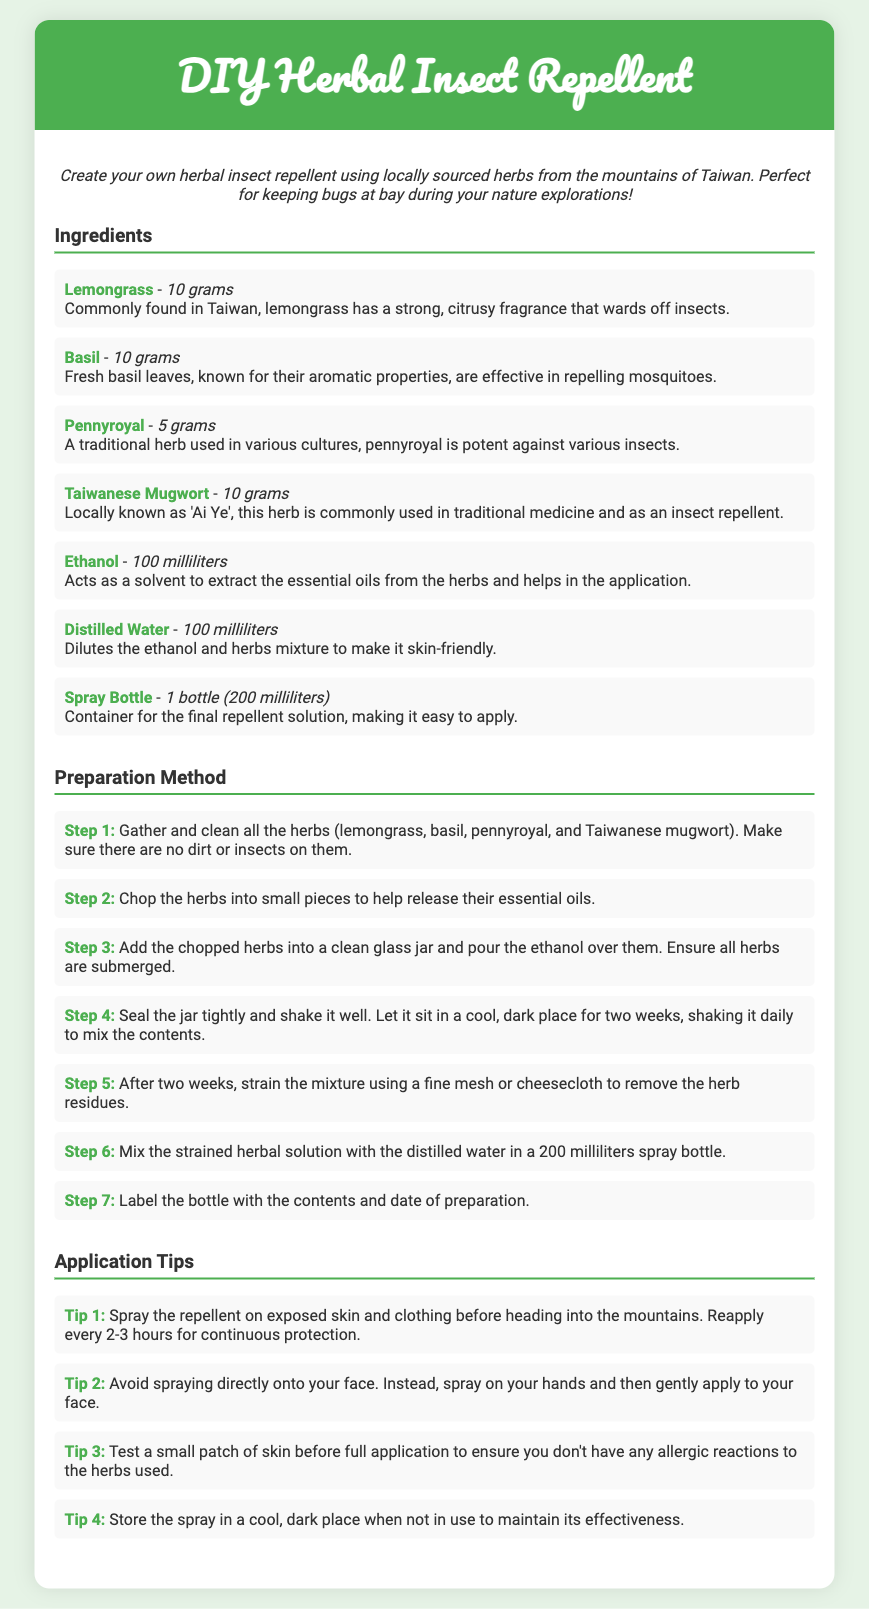what is the main purpose of the DIY Herbal Insect Repellent? The purpose is to create a herbal insect repellent using locally sourced herbs for nature explorations.
Answer: create a herbal insect repellent how many grams of basil are needed? The document lists the quantity needed for basil as part of the ingredients.
Answer: 10 grams which local herb is also known as 'Ai Ye'? The document specifies which herb is commonly known by this name.
Answer: Taiwanese Mugwort what should be done with the mixture after two weeks? This asks for the next step provided in the preparation method after the specified duration.
Answer: strain the mixture how often should the repellent be reapplied? This information is found in the application tips section regarding how frequently to reapply the repellent.
Answer: every 2-3 hours what is the total volume of distilled water required? This question is regarding the amount of distilled water specified in the ingredients.
Answer: 100 milliliters which ingredient acts as a solvent? This requires identifying the ingredient specifically mentioned as a solvent.
Answer: Ethanol how should the spray be applied to the face? This questions asks for the recommended technique for applying the spray to the face, as per the tips provided.
Answer: spray on hands and then apply 